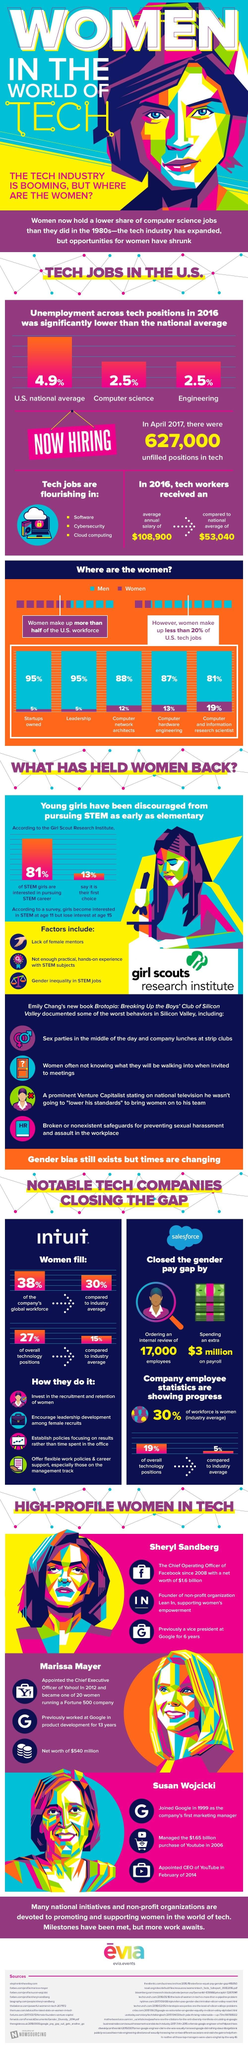Outline some significant characteristics in this image. According to a recent study, over 95% of startups are owned by men. According to recent data, 19% of women in the US workforce hold the job title of computer and information research scientist. Approximately 19% of computer and information research scientists are women. The most in-demand technology-based careers for growth are software development, cybersecurity, and cloud computing. According to data, only 12% of women hold the occupation of computer network architect. 